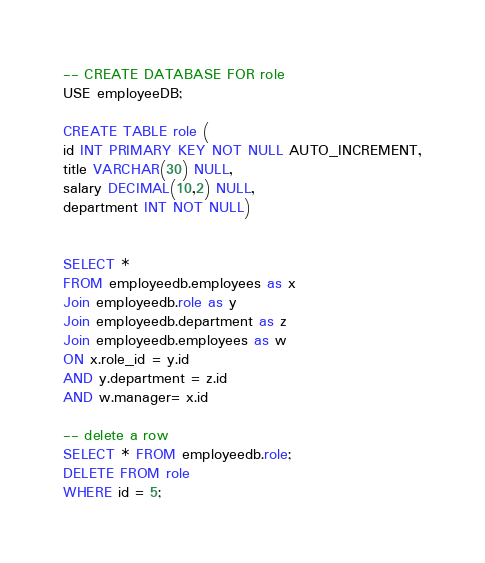Convert code to text. <code><loc_0><loc_0><loc_500><loc_500><_SQL_>
-- CREATE DATABASE FOR role
USE employeeDB;

CREATE TABLE role (
id INT PRIMARY KEY NOT NULL AUTO_INCREMENT,
title VARCHAR(30) NULL,
salary DECIMAL(10,2) NULL,
department INT NOT NULL)


SELECT * 
FROM employeedb.employees as x 
Join employeedb.role as y 
Join employeedb.department as z 
Join employeedb.employees as w 
ON x.role_id = y.id 
AND y.department = z.id
AND w.manager= x.id

-- delete a row
SELECT * FROM employeedb.role;
DELETE FROM role
WHERE id = 5;</code> 